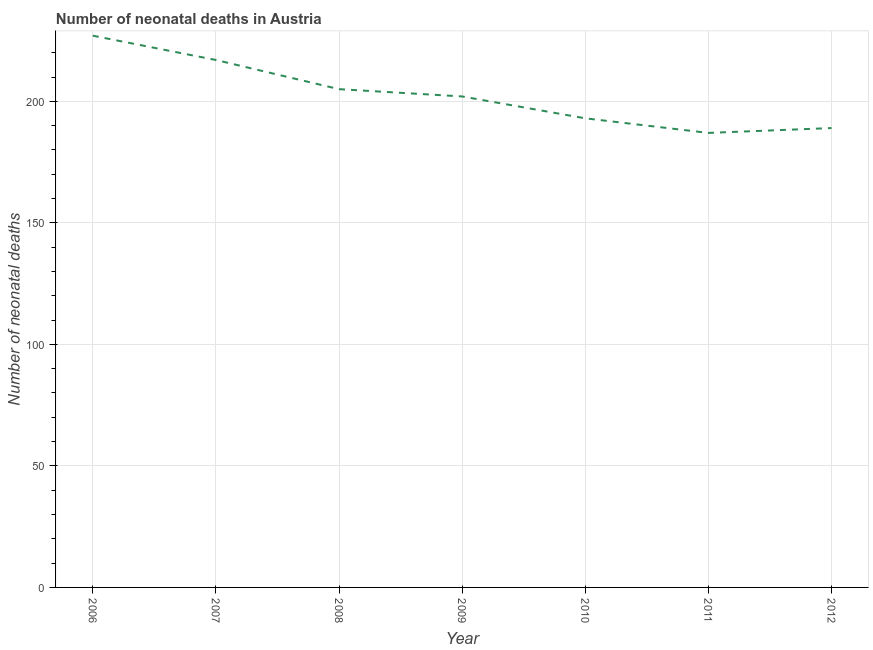What is the number of neonatal deaths in 2010?
Keep it short and to the point. 193. Across all years, what is the maximum number of neonatal deaths?
Provide a short and direct response. 227. Across all years, what is the minimum number of neonatal deaths?
Offer a terse response. 187. In which year was the number of neonatal deaths maximum?
Your answer should be compact. 2006. In which year was the number of neonatal deaths minimum?
Make the answer very short. 2011. What is the sum of the number of neonatal deaths?
Give a very brief answer. 1420. What is the difference between the number of neonatal deaths in 2008 and 2011?
Offer a very short reply. 18. What is the average number of neonatal deaths per year?
Offer a terse response. 202.86. What is the median number of neonatal deaths?
Your answer should be very brief. 202. What is the ratio of the number of neonatal deaths in 2007 to that in 2011?
Your response must be concise. 1.16. Is the number of neonatal deaths in 2006 less than that in 2011?
Your response must be concise. No. What is the difference between the highest and the second highest number of neonatal deaths?
Provide a short and direct response. 10. What is the difference between the highest and the lowest number of neonatal deaths?
Give a very brief answer. 40. In how many years, is the number of neonatal deaths greater than the average number of neonatal deaths taken over all years?
Your answer should be very brief. 3. How many years are there in the graph?
Your response must be concise. 7. What is the difference between two consecutive major ticks on the Y-axis?
Offer a terse response. 50. Does the graph contain any zero values?
Give a very brief answer. No. Does the graph contain grids?
Make the answer very short. Yes. What is the title of the graph?
Your answer should be compact. Number of neonatal deaths in Austria. What is the label or title of the Y-axis?
Offer a very short reply. Number of neonatal deaths. What is the Number of neonatal deaths in 2006?
Your response must be concise. 227. What is the Number of neonatal deaths in 2007?
Offer a very short reply. 217. What is the Number of neonatal deaths of 2008?
Keep it short and to the point. 205. What is the Number of neonatal deaths of 2009?
Your response must be concise. 202. What is the Number of neonatal deaths of 2010?
Ensure brevity in your answer.  193. What is the Number of neonatal deaths in 2011?
Ensure brevity in your answer.  187. What is the Number of neonatal deaths in 2012?
Give a very brief answer. 189. What is the difference between the Number of neonatal deaths in 2006 and 2008?
Offer a terse response. 22. What is the difference between the Number of neonatal deaths in 2006 and 2010?
Your answer should be compact. 34. What is the difference between the Number of neonatal deaths in 2006 and 2012?
Offer a terse response. 38. What is the difference between the Number of neonatal deaths in 2007 and 2009?
Make the answer very short. 15. What is the difference between the Number of neonatal deaths in 2007 and 2010?
Your answer should be compact. 24. What is the difference between the Number of neonatal deaths in 2007 and 2011?
Your response must be concise. 30. What is the difference between the Number of neonatal deaths in 2007 and 2012?
Offer a very short reply. 28. What is the difference between the Number of neonatal deaths in 2008 and 2009?
Your answer should be compact. 3. What is the difference between the Number of neonatal deaths in 2008 and 2011?
Keep it short and to the point. 18. What is the difference between the Number of neonatal deaths in 2008 and 2012?
Your answer should be very brief. 16. What is the difference between the Number of neonatal deaths in 2009 and 2010?
Your answer should be compact. 9. What is the difference between the Number of neonatal deaths in 2009 and 2011?
Your response must be concise. 15. What is the difference between the Number of neonatal deaths in 2010 and 2011?
Your response must be concise. 6. What is the difference between the Number of neonatal deaths in 2011 and 2012?
Your response must be concise. -2. What is the ratio of the Number of neonatal deaths in 2006 to that in 2007?
Your answer should be compact. 1.05. What is the ratio of the Number of neonatal deaths in 2006 to that in 2008?
Your response must be concise. 1.11. What is the ratio of the Number of neonatal deaths in 2006 to that in 2009?
Your answer should be compact. 1.12. What is the ratio of the Number of neonatal deaths in 2006 to that in 2010?
Keep it short and to the point. 1.18. What is the ratio of the Number of neonatal deaths in 2006 to that in 2011?
Your response must be concise. 1.21. What is the ratio of the Number of neonatal deaths in 2006 to that in 2012?
Your response must be concise. 1.2. What is the ratio of the Number of neonatal deaths in 2007 to that in 2008?
Provide a short and direct response. 1.06. What is the ratio of the Number of neonatal deaths in 2007 to that in 2009?
Your answer should be very brief. 1.07. What is the ratio of the Number of neonatal deaths in 2007 to that in 2010?
Your answer should be compact. 1.12. What is the ratio of the Number of neonatal deaths in 2007 to that in 2011?
Offer a terse response. 1.16. What is the ratio of the Number of neonatal deaths in 2007 to that in 2012?
Give a very brief answer. 1.15. What is the ratio of the Number of neonatal deaths in 2008 to that in 2010?
Your answer should be compact. 1.06. What is the ratio of the Number of neonatal deaths in 2008 to that in 2011?
Offer a very short reply. 1.1. What is the ratio of the Number of neonatal deaths in 2008 to that in 2012?
Make the answer very short. 1.08. What is the ratio of the Number of neonatal deaths in 2009 to that in 2010?
Offer a terse response. 1.05. What is the ratio of the Number of neonatal deaths in 2009 to that in 2011?
Provide a short and direct response. 1.08. What is the ratio of the Number of neonatal deaths in 2009 to that in 2012?
Your answer should be compact. 1.07. What is the ratio of the Number of neonatal deaths in 2010 to that in 2011?
Ensure brevity in your answer.  1.03. What is the ratio of the Number of neonatal deaths in 2011 to that in 2012?
Give a very brief answer. 0.99. 